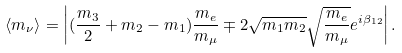<formula> <loc_0><loc_0><loc_500><loc_500>\langle m _ { \nu } \rangle = \left | ( \frac { m _ { 3 } } { 2 } + m _ { 2 } - m _ { 1 } ) \frac { m _ { e } } { m _ { \mu } } \mp 2 \sqrt { m _ { 1 } m _ { 2 } } \sqrt { \frac { m _ { e } } { m _ { \mu } } } e ^ { i \beta _ { 1 2 } } \right | .</formula> 